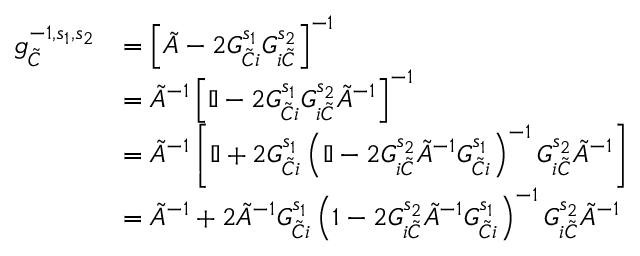<formula> <loc_0><loc_0><loc_500><loc_500>\begin{array} { r l } { g _ { \tilde { C } } ^ { - 1 , s _ { 1 } , s _ { 2 } } } & { = \left [ \tilde { A } - 2 G _ { \tilde { C } i } ^ { s _ { 1 } } G _ { i \tilde { C } } ^ { s _ { 2 } } \right ] ^ { - 1 } } \\ & { = \tilde { A } ^ { - 1 } \left [ \mathbb { I } - 2 G _ { \tilde { C } i } ^ { s _ { 1 } } G _ { i \tilde { C } } ^ { s _ { 2 } } \tilde { A } ^ { - 1 } \right ] ^ { - 1 } } \\ & { = \tilde { A } ^ { - 1 } \left [ \mathbb { I } + 2 G _ { \tilde { C } i } ^ { s _ { 1 } } \left ( \mathbb { I } - 2 G _ { i \tilde { C } } ^ { s _ { 2 } } \tilde { A } ^ { - 1 } G _ { \tilde { C } i } ^ { s _ { 1 } } \right ) ^ { - 1 } G _ { i \tilde { C } } ^ { s _ { 2 } } \tilde { A } ^ { - 1 } \right ] } \\ & { = \tilde { A } ^ { - 1 } + 2 \tilde { A } ^ { - 1 } G _ { \tilde { C } i } ^ { s _ { 1 } } \left ( 1 - 2 G _ { i \tilde { C } } ^ { s _ { 2 } } \tilde { A } ^ { - 1 } G _ { \tilde { C } i } ^ { s _ { 1 } } \right ) ^ { - 1 } G _ { i \tilde { C } } ^ { s _ { 2 } } \tilde { A } ^ { - 1 } } \end{array}</formula> 